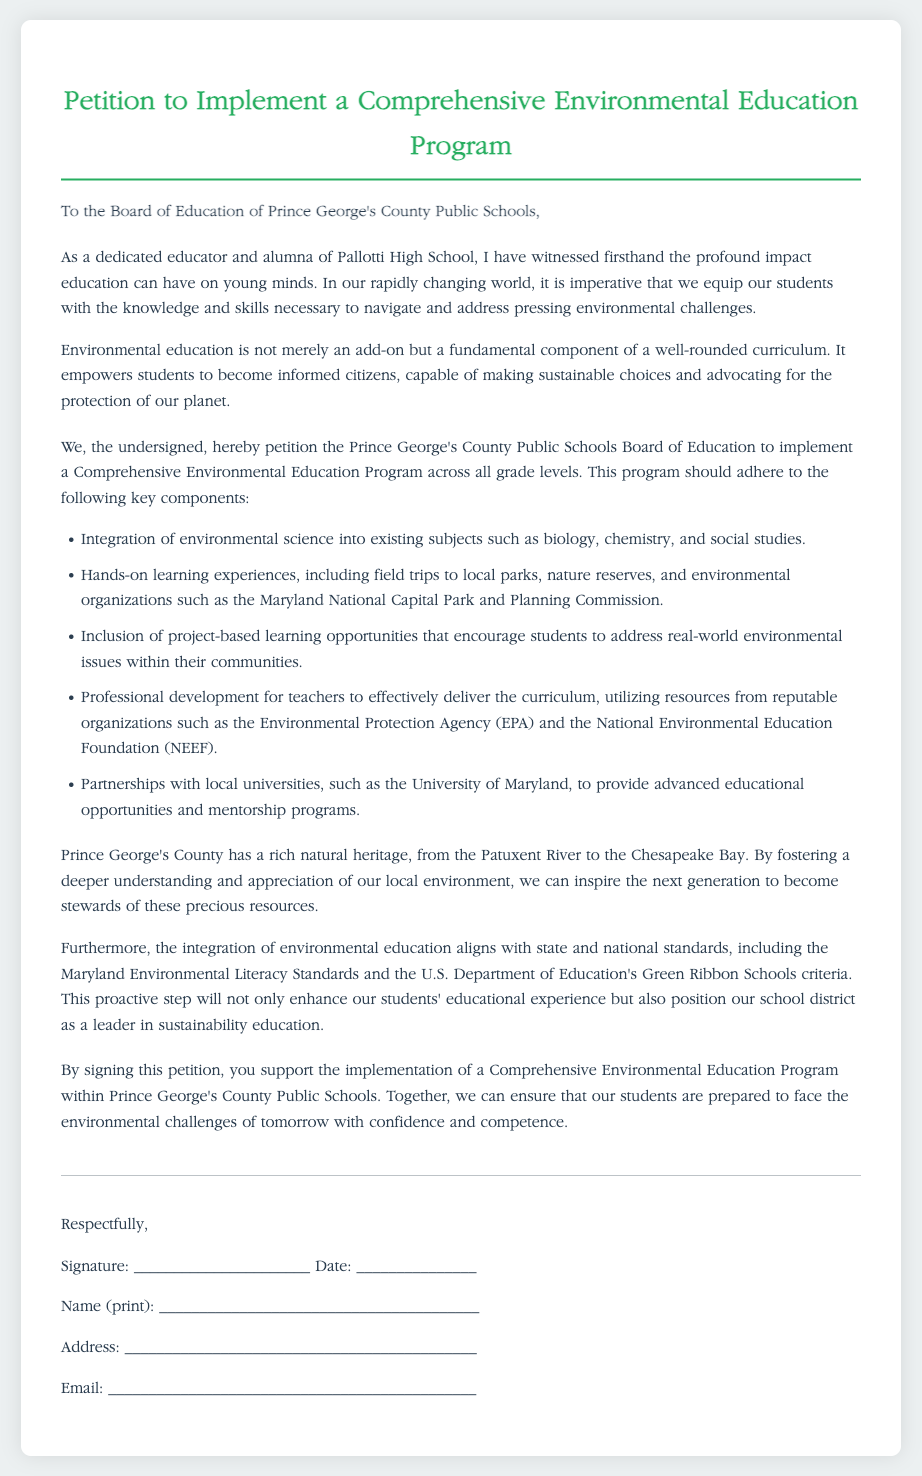what is the title of the petition? The title of the petition is the main heading of the document, indicating the topic addressed.
Answer: Petition to Implement a Comprehensive Environmental Education Program who is the petition addressed to? The petition is addressed to the specific body responsible for educational matters in Prince George's County.
Answer: Board of Education of Prince George's County Public Schools what is one key component of the proposed program? Key components are listed as specific actions that the petitioners want to include in the program.
Answer: Integration of environmental science into existing subjects which natural heritage features are mentioned? The document references notable natural areas within Prince George's County that are part of its heritage and environment.
Answer: Patuxent River and Chesapeake Bay who is signing the petition? This section lists who is expected to provide their support by signing and providing their details.
Answer: The undersigned how is environmental education described in the document? The description focuses on the role and importance of environmental education as per the views expressed in the petition.
Answer: Fundamental component of a well-rounded curriculum what is the stated goal of the petition? The goal reflects the overarching intention behind creating the petition and what it wishes to achieve.
Answer: Implement a Comprehensive Environmental Education Program which university is mentioned for partnership opportunities? The mention of a university indicates a collaboration that could enhance educational offerings.
Answer: University of Maryland 